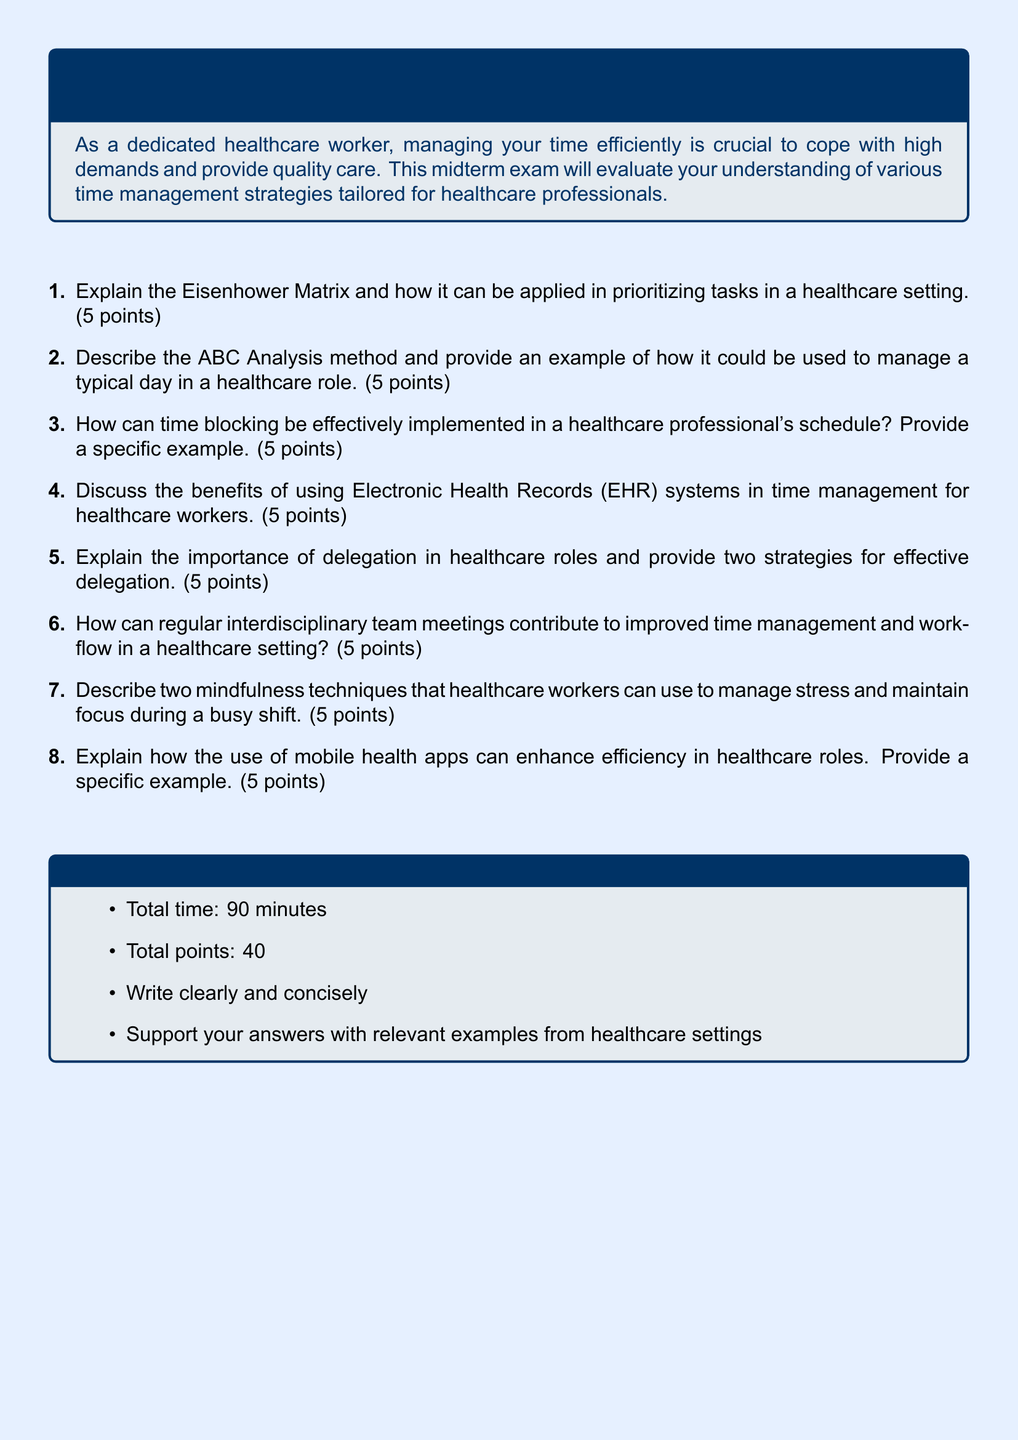What is the total number of points for the exam? The total points for the exam is explicitly stated in the guidelines section.
Answer: 40 What is the duration of the exam? The total time allotted for the exam is mentioned in the guidelines section.
Answer: 90 minutes How many points is each question worth? Each question on the exam carries a specific number of points as indicated in the document.
Answer: 5 points What is the title of the midterm exam? The title of the midterm exam is clearly listed at the beginning of the document.
Answer: Strategies for Efficient Time Management in Healthcare Roles What are the two strategies for effective delegation mentioned? The document prompts for two strategies for effective delegation but does not specify them. The exam tests the ability to provide those strategies.
Answer: [Open-ended, requires student’s input] What is the first item listed in the exam questions? The questions start with a specific first item that is part of the exam requirements.
Answer: Explain the Eisenhower Matrix and how it can be applied in prioritizing tasks in a healthcare setting How can mindfulness techniques assist healthcare workers? The document lists mindfulness techniques as a strategy but requires reasoning to answer how they assist.
Answer: [Open-ended, requires student’s input] What font is used in the document? The document specifies the font used throughout its content.
Answer: Arial 